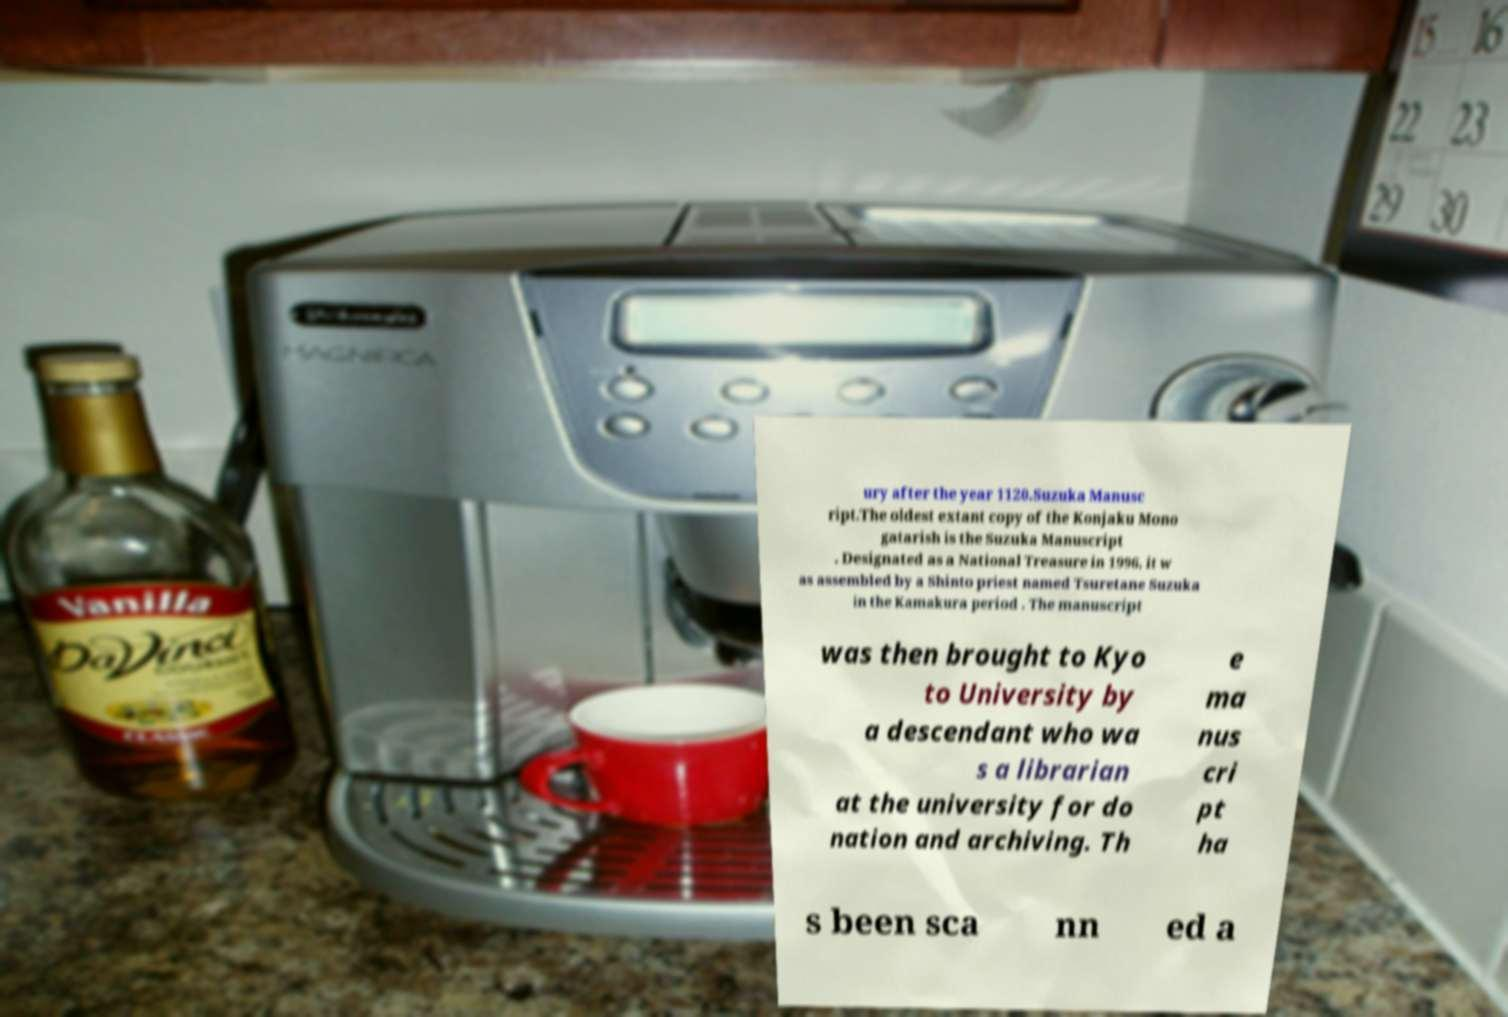Please identify and transcribe the text found in this image. ury after the year 1120.Suzuka Manusc ript.The oldest extant copy of the Konjaku Mono gatarish is the Suzuka Manuscript . Designated as a National Treasure in 1996, it w as assembled by a Shinto priest named Tsuretane Suzuka in the Kamakura period . The manuscript was then brought to Kyo to University by a descendant who wa s a librarian at the university for do nation and archiving. Th e ma nus cri pt ha s been sca nn ed a 